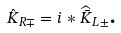Convert formula to latex. <formula><loc_0><loc_0><loc_500><loc_500>\hat { K } _ { R \mp } = i \ast \widehat { \bar { K } } _ { L \pm } \text {.}</formula> 